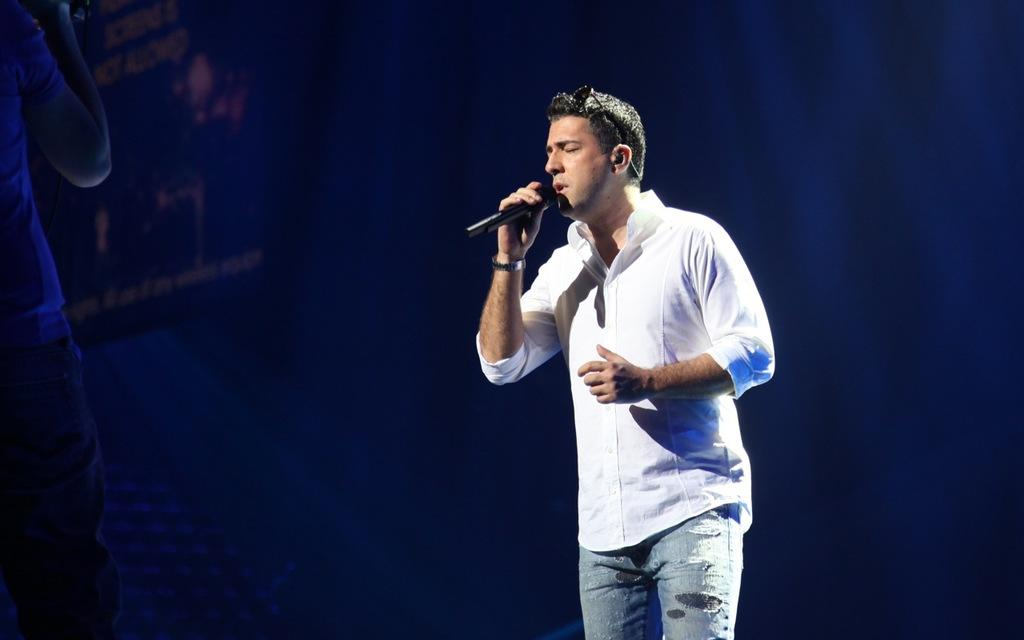What is the man in the image doing? The man is standing and singing a song. What object is the man holding in the image? The man is holding a microphone. What can be seen in the background of the image? There is a screen in the background of the image. What type of soda is the man drinking while singing in the image? There is no soda present in the image; the man is holding a microphone and singing. What adjustment is the man making to the ground in the image? There is no adjustment being made to the ground in the image; the man is singing and holding a microphone. 